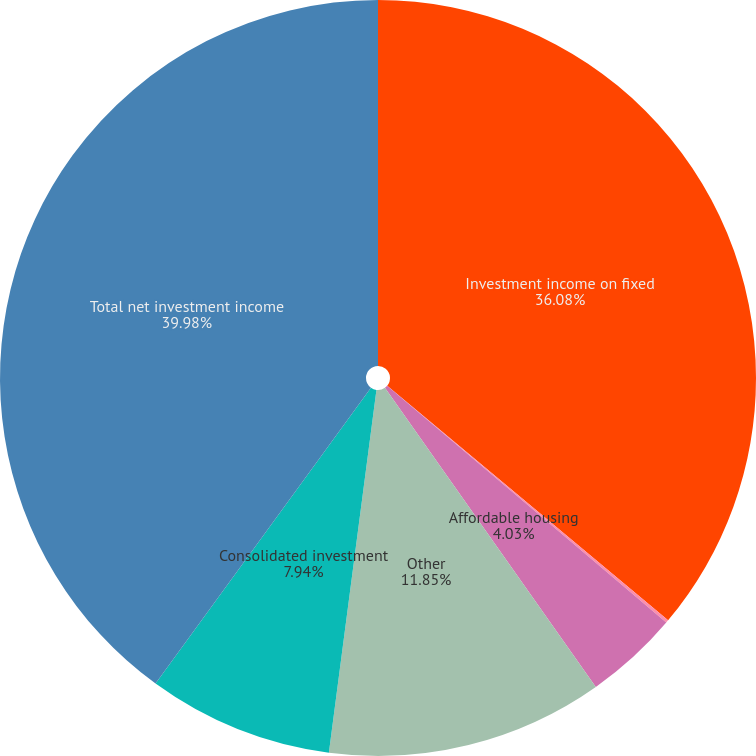Convert chart. <chart><loc_0><loc_0><loc_500><loc_500><pie_chart><fcel>Investment income on fixed<fcel>Net realized gains<fcel>Affordable housing<fcel>Other<fcel>Consolidated investment<fcel>Total net investment income<nl><fcel>36.08%<fcel>0.12%<fcel>4.03%<fcel>11.85%<fcel>7.94%<fcel>39.99%<nl></chart> 